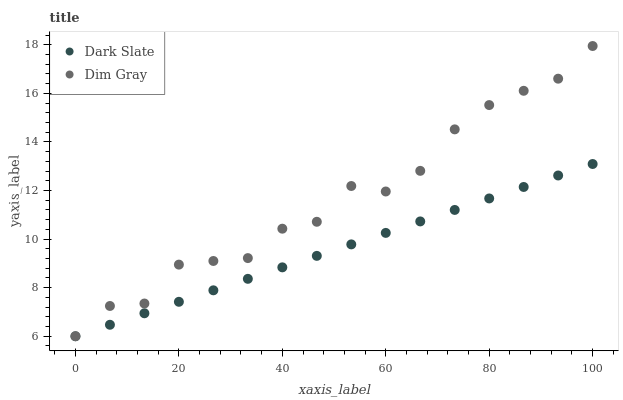Does Dark Slate have the minimum area under the curve?
Answer yes or no. Yes. Does Dim Gray have the maximum area under the curve?
Answer yes or no. Yes. Does Dim Gray have the minimum area under the curve?
Answer yes or no. No. Is Dark Slate the smoothest?
Answer yes or no. Yes. Is Dim Gray the roughest?
Answer yes or no. Yes. Is Dim Gray the smoothest?
Answer yes or no. No. Does Dark Slate have the lowest value?
Answer yes or no. Yes. Does Dim Gray have the highest value?
Answer yes or no. Yes. Does Dark Slate intersect Dim Gray?
Answer yes or no. Yes. Is Dark Slate less than Dim Gray?
Answer yes or no. No. Is Dark Slate greater than Dim Gray?
Answer yes or no. No. 